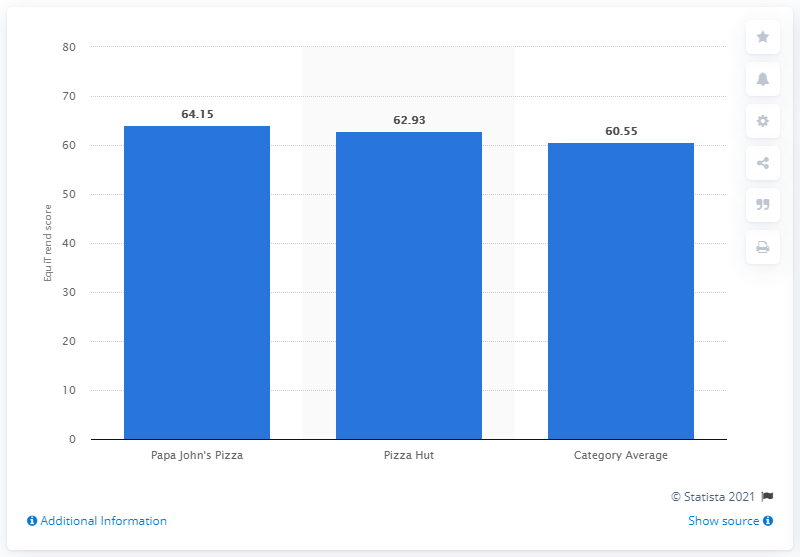Indicate a few pertinent items in this graphic. Papa John's Pizza received a EquiTrend score of 64.15 in 2012, indicating a positive overall sentiment towards the brand. 